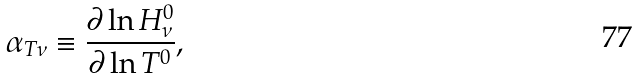Convert formula to latex. <formula><loc_0><loc_0><loc_500><loc_500>\alpha _ { T \nu } \equiv \frac { \partial \ln H _ { \nu } ^ { 0 } } { \partial \ln T ^ { 0 } } ,</formula> 